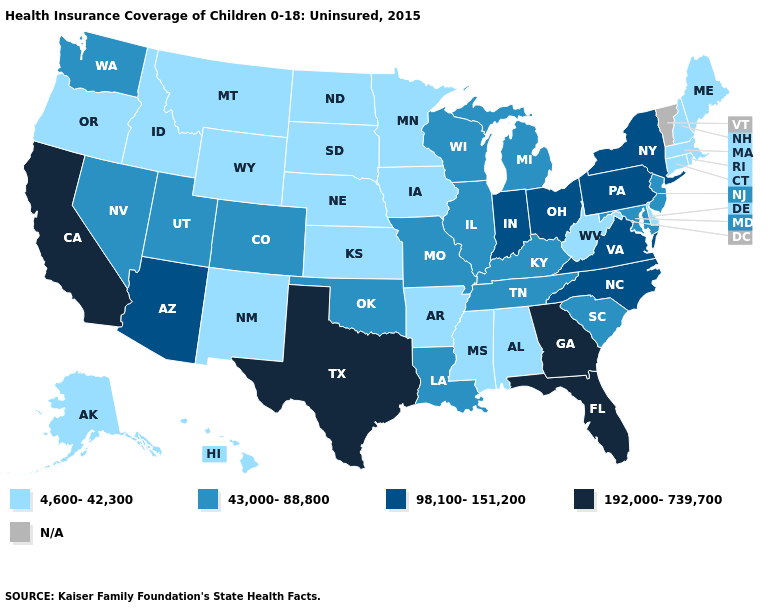Name the states that have a value in the range 192,000-739,700?
Quick response, please. California, Florida, Georgia, Texas. What is the highest value in the South ?
Short answer required. 192,000-739,700. What is the value of Wyoming?
Write a very short answer. 4,600-42,300. How many symbols are there in the legend?
Quick response, please. 5. Name the states that have a value in the range 98,100-151,200?
Answer briefly. Arizona, Indiana, New York, North Carolina, Ohio, Pennsylvania, Virginia. Does Nebraska have the lowest value in the USA?
Write a very short answer. Yes. Name the states that have a value in the range 98,100-151,200?
Keep it brief. Arizona, Indiana, New York, North Carolina, Ohio, Pennsylvania, Virginia. What is the value of Alabama?
Short answer required. 4,600-42,300. Does Louisiana have the lowest value in the USA?
Answer briefly. No. What is the value of North Dakota?
Short answer required. 4,600-42,300. Which states have the lowest value in the USA?
Keep it brief. Alabama, Alaska, Arkansas, Connecticut, Delaware, Hawaii, Idaho, Iowa, Kansas, Maine, Massachusetts, Minnesota, Mississippi, Montana, Nebraska, New Hampshire, New Mexico, North Dakota, Oregon, Rhode Island, South Dakota, West Virginia, Wyoming. Name the states that have a value in the range 43,000-88,800?
Short answer required. Colorado, Illinois, Kentucky, Louisiana, Maryland, Michigan, Missouri, Nevada, New Jersey, Oklahoma, South Carolina, Tennessee, Utah, Washington, Wisconsin. Which states have the lowest value in the USA?
Quick response, please. Alabama, Alaska, Arkansas, Connecticut, Delaware, Hawaii, Idaho, Iowa, Kansas, Maine, Massachusetts, Minnesota, Mississippi, Montana, Nebraska, New Hampshire, New Mexico, North Dakota, Oregon, Rhode Island, South Dakota, West Virginia, Wyoming. What is the lowest value in states that border Kentucky?
Answer briefly. 4,600-42,300. Does the first symbol in the legend represent the smallest category?
Answer briefly. Yes. 